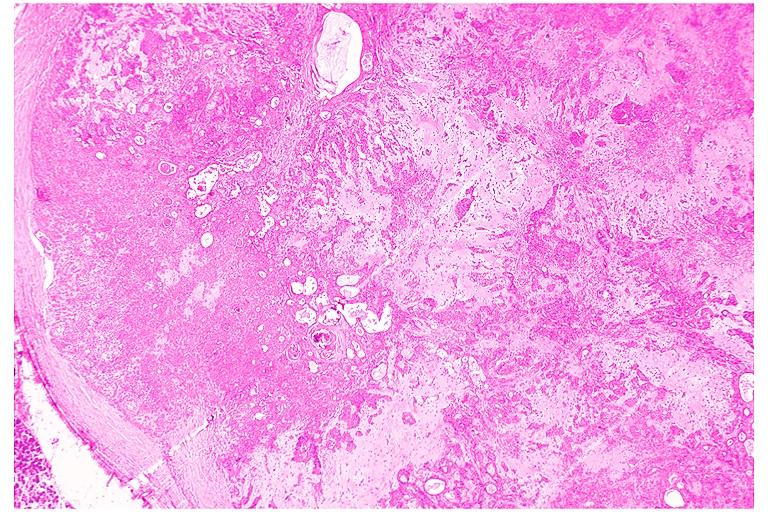what does this image show?
Answer the question using a single word or phrase. Pleomorphic adenoma benign mixed tumor 